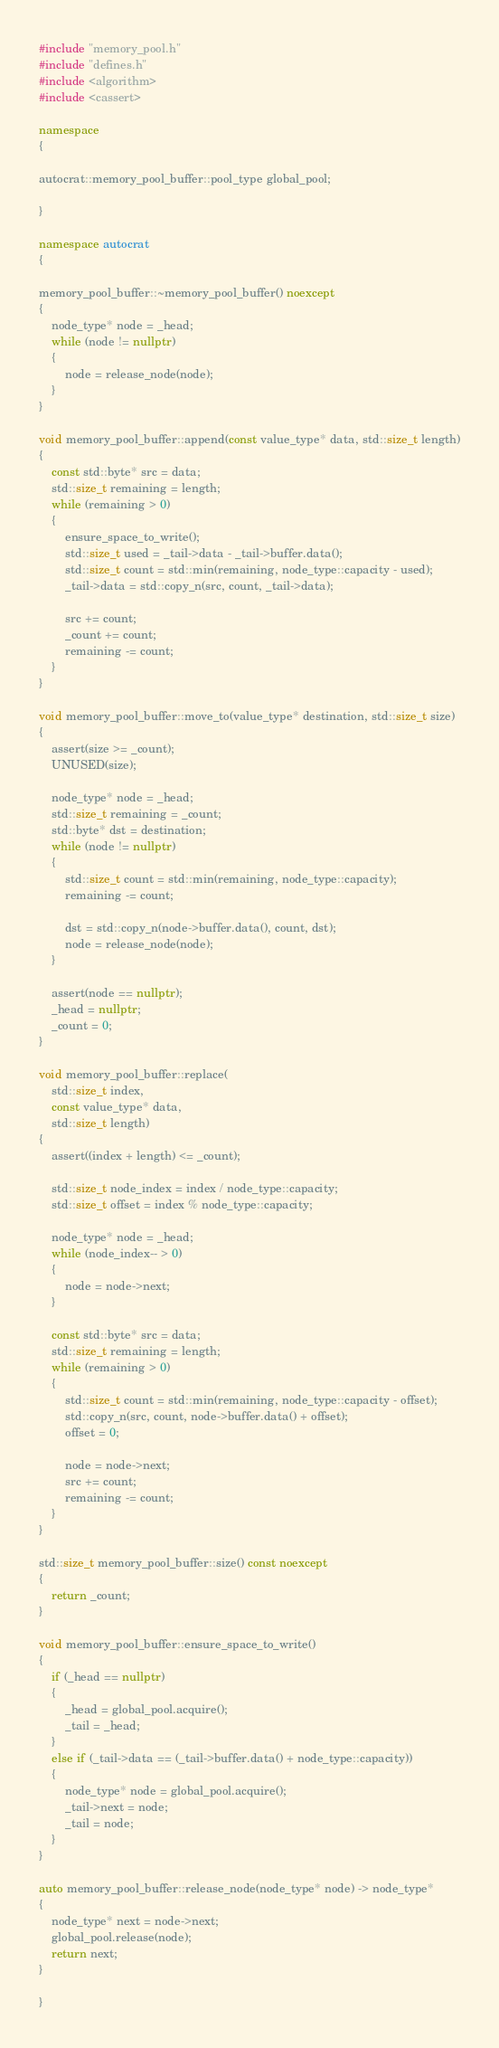<code> <loc_0><loc_0><loc_500><loc_500><_C++_>#include "memory_pool.h"
#include "defines.h"
#include <algorithm>
#include <cassert>

namespace
{

autocrat::memory_pool_buffer::pool_type global_pool;

}

namespace autocrat
{

memory_pool_buffer::~memory_pool_buffer() noexcept
{
    node_type* node = _head;
    while (node != nullptr)
    {
        node = release_node(node);
    }
}

void memory_pool_buffer::append(const value_type* data, std::size_t length)
{
    const std::byte* src = data;
    std::size_t remaining = length;
    while (remaining > 0)
    {
        ensure_space_to_write();
        std::size_t used = _tail->data - _tail->buffer.data();
        std::size_t count = std::min(remaining, node_type::capacity - used);
        _tail->data = std::copy_n(src, count, _tail->data);

        src += count;
        _count += count;
        remaining -= count;
    }
}

void memory_pool_buffer::move_to(value_type* destination, std::size_t size)
{
    assert(size >= _count);
    UNUSED(size);

    node_type* node = _head;
    std::size_t remaining = _count;
    std::byte* dst = destination;
    while (node != nullptr)
    {
        std::size_t count = std::min(remaining, node_type::capacity);
        remaining -= count;

        dst = std::copy_n(node->buffer.data(), count, dst);
        node = release_node(node);
    }

    assert(node == nullptr);
    _head = nullptr;
    _count = 0;
}

void memory_pool_buffer::replace(
    std::size_t index,
    const value_type* data,
    std::size_t length)
{
    assert((index + length) <= _count);

    std::size_t node_index = index / node_type::capacity;
    std::size_t offset = index % node_type::capacity;

    node_type* node = _head;
    while (node_index-- > 0)
    {
        node = node->next;
    }

    const std::byte* src = data;
    std::size_t remaining = length;
    while (remaining > 0)
    {
        std::size_t count = std::min(remaining, node_type::capacity - offset);
        std::copy_n(src, count, node->buffer.data() + offset);
        offset = 0;

        node = node->next;
        src += count;
        remaining -= count;
    }
}

std::size_t memory_pool_buffer::size() const noexcept
{
    return _count;
}

void memory_pool_buffer::ensure_space_to_write()
{
    if (_head == nullptr)
    {
        _head = global_pool.acquire();
        _tail = _head;
    }
    else if (_tail->data == (_tail->buffer.data() + node_type::capacity))
    {
        node_type* node = global_pool.acquire();
        _tail->next = node;
        _tail = node;
    }
}

auto memory_pool_buffer::release_node(node_type* node) -> node_type*
{
    node_type* next = node->next;
    global_pool.release(node);
    return next;
}

}
</code> 